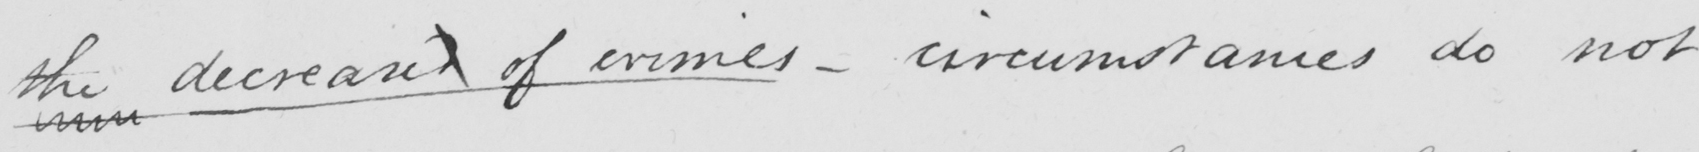Can you read and transcribe this handwriting? the decreased of crimes  _  circumstances do not 